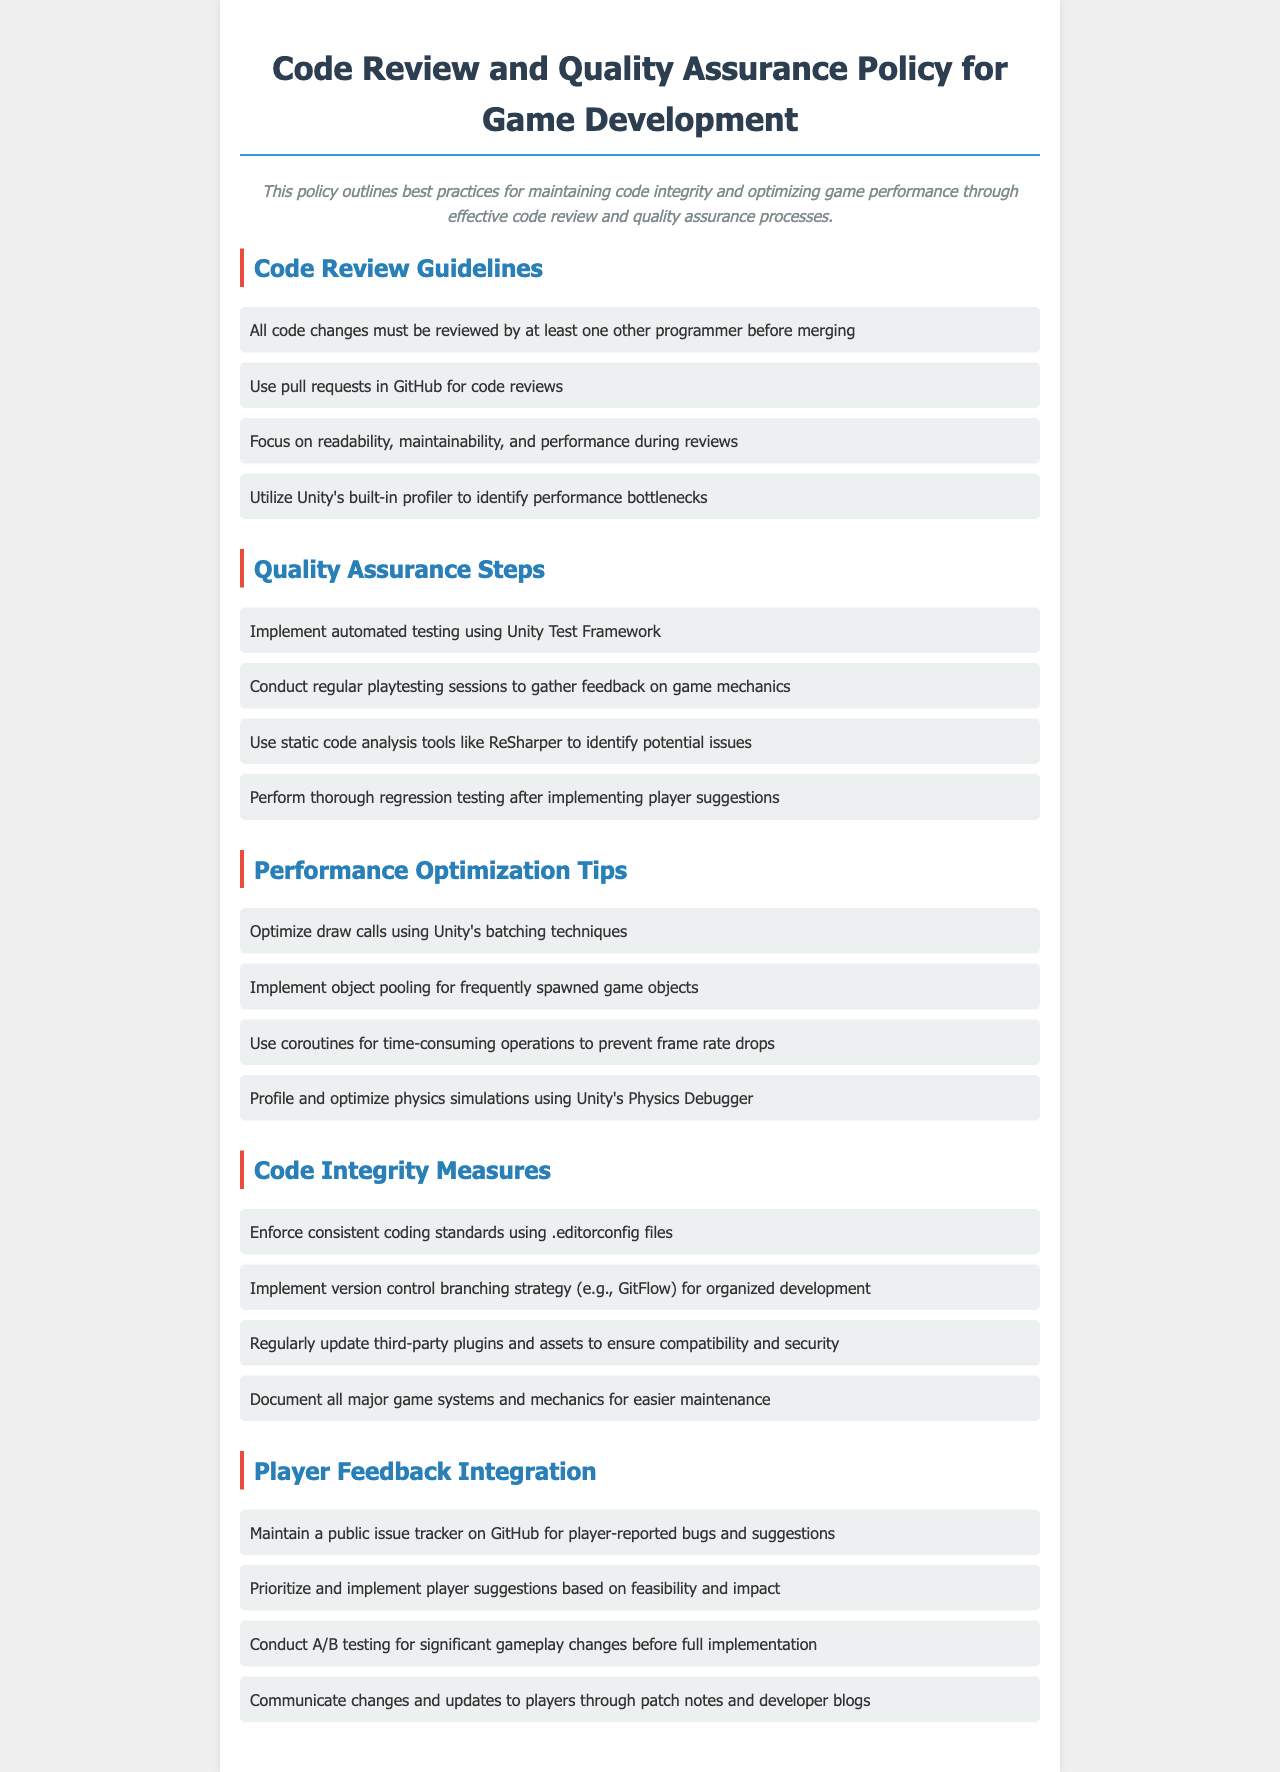What are the Code Review Guidelines? The Code Review Guidelines list practices to ensure code quality, such as requiring reviews by another programmer and using pull requests.
Answer: All code changes must be reviewed by at least one other programmer before merging What framework should be used for automated testing? The document specifies that Unity Test Framework is recommended for automated testing for quality assurance.
Answer: Unity Test Framework What technique is suggested for optimizing draw calls? The document mentions using batching techniques available in Unity for optimizing draw calls.
Answer: Unity's batching techniques What is a suggested step for integrating player feedback? The document states that maintaining a public issue tracker is a key step in integrating player feedback.
Answer: Public issue tracker How many quality assurance steps are listed? The document outlines several steps for quality assurance; counting them provides the total number.
Answer: Four 